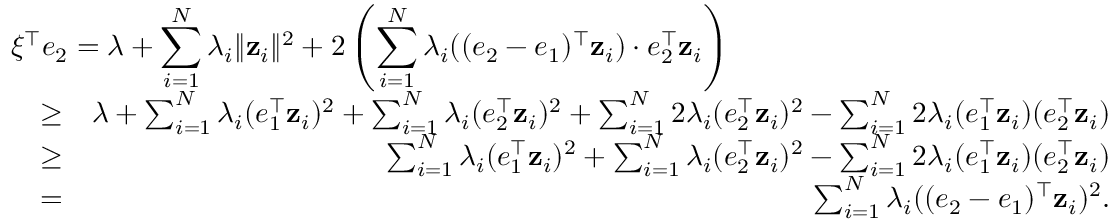Convert formula to latex. <formula><loc_0><loc_0><loc_500><loc_500>\begin{array} { r l r } { { \xi ^ { \top } e _ { 2 } = \lambda + \sum _ { i = 1 } ^ { N } \lambda _ { i } \| \mathbf z _ { i } \| ^ { 2 } + 2 \left ( \sum _ { i = 1 } ^ { N } \lambda _ { i } ( ( e _ { 2 } - e _ { 1 } ) ^ { \top } \mathbf z _ { i } ) \cdot e _ { 2 } ^ { \top } \mathbf z _ { i } \right ) } } \\ & { \geq } & { \lambda + \sum _ { i = 1 } ^ { N } \lambda _ { i } ( e _ { 1 } ^ { \top } \mathbf z _ { i } ) ^ { 2 } + \sum _ { i = 1 } ^ { N } \lambda _ { i } ( e _ { 2 } ^ { \top } \mathbf z _ { i } ) ^ { 2 } + \sum _ { i = 1 } ^ { N } 2 \lambda _ { i } ( e _ { 2 } ^ { \top } \mathbf z _ { i } ) ^ { 2 } - \sum _ { i = 1 } ^ { N } 2 \lambda _ { i } ( e _ { 1 } ^ { \top } \mathbf z _ { i } ) ( e _ { 2 } ^ { \top } \mathbf z _ { i } ) } \\ & { \geq } & { \sum _ { i = 1 } ^ { N } \lambda _ { i } ( e _ { 1 } ^ { \top } \mathbf z _ { i } ) ^ { 2 } + \sum _ { i = 1 } ^ { N } \lambda _ { i } ( e _ { 2 } ^ { \top } \mathbf z _ { i } ) ^ { 2 } - \sum _ { i = 1 } ^ { N } 2 \lambda _ { i } ( e _ { 1 } ^ { \top } \mathbf z _ { i } ) ( e _ { 2 } ^ { \top } \mathbf z _ { i } ) } \\ & { = } & { \sum _ { i = 1 } ^ { N } \lambda _ { i } ( ( e _ { 2 } - e _ { 1 } ) ^ { \top } \mathbf z _ { i } ) ^ { 2 } . } \end{array}</formula> 